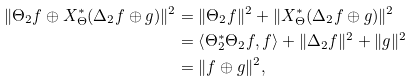<formula> <loc_0><loc_0><loc_500><loc_500>\| \Theta _ { 2 } f \oplus X _ { \Theta } ^ { * } ( \Delta _ { 2 } f \oplus g ) \| ^ { 2 } & = \| \Theta _ { 2 } f \| ^ { 2 } + \| X _ { \Theta } ^ { * } ( \Delta _ { 2 } f \oplus g ) \| ^ { 2 } \\ & = \left < \Theta _ { 2 } ^ { * } \Theta _ { 2 } f , f \right > + \| \Delta _ { 2 } f \| ^ { 2 } + \| g \| ^ { 2 } \\ & = \| f \oplus g \| ^ { 2 } ,</formula> 